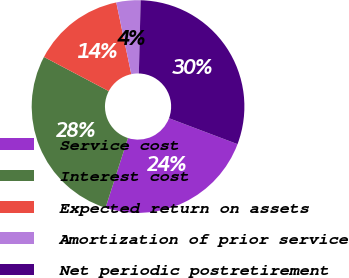Convert chart. <chart><loc_0><loc_0><loc_500><loc_500><pie_chart><fcel>Service cost<fcel>Interest cost<fcel>Expected return on assets<fcel>Amortization of prior service<fcel>Net periodic postretirement<nl><fcel>24.19%<fcel>27.77%<fcel>14.0%<fcel>3.67%<fcel>30.36%<nl></chart> 